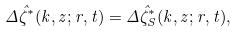<formula> <loc_0><loc_0><loc_500><loc_500>\Delta \hat { \zeta } ^ { * } ( k , z ; r , t ) = \Delta \hat { \zeta } ^ { * } _ { S } ( k , z ; r , t ) ,</formula> 